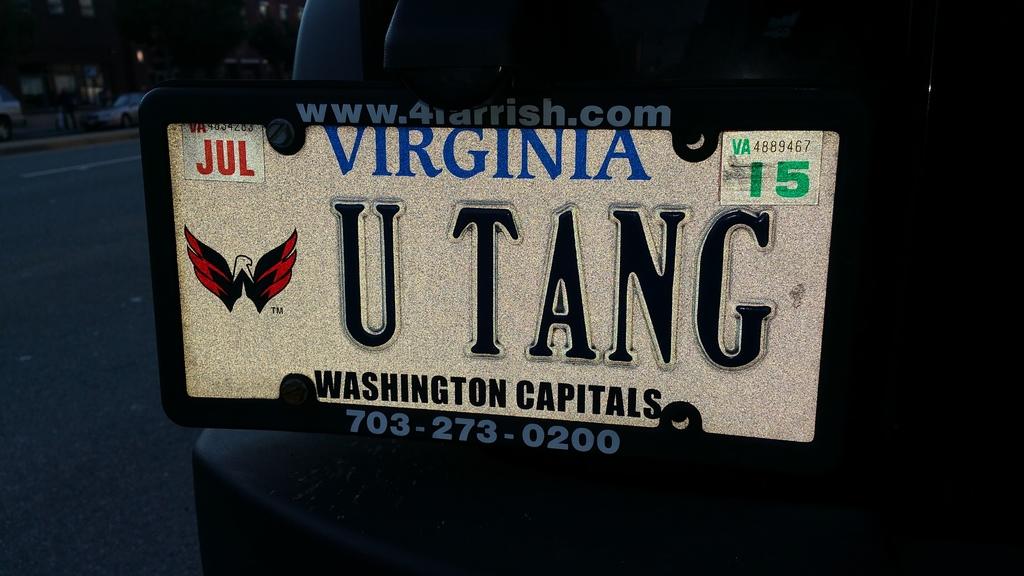What state is on the license tag?
Offer a terse response. Virginia. What is the phone number displayed at bottom of license plate?
Keep it short and to the point. 703-273-0200. 